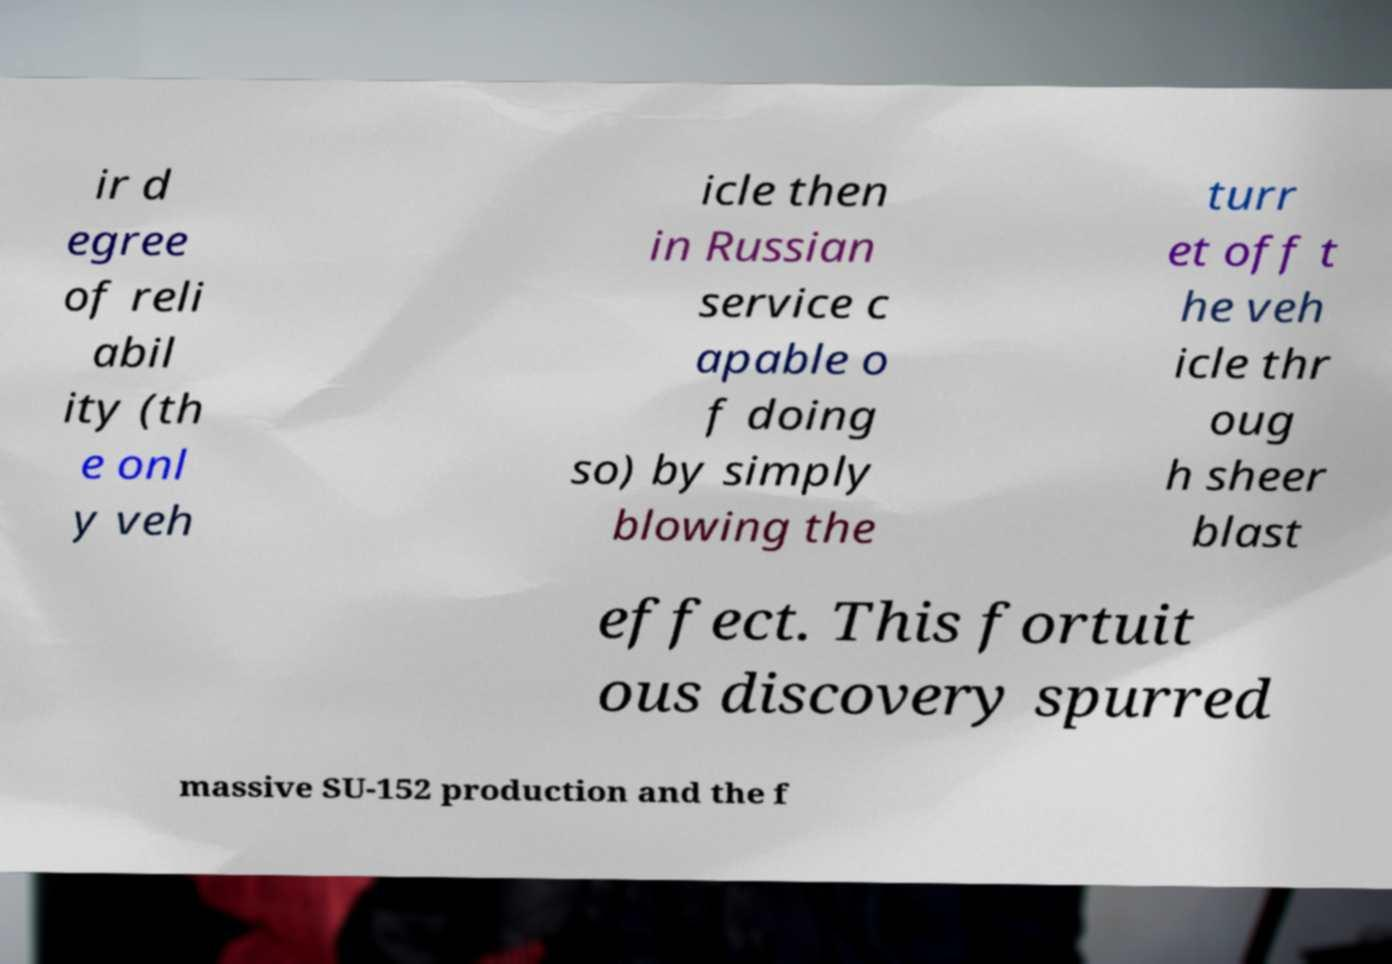For documentation purposes, I need the text within this image transcribed. Could you provide that? ir d egree of reli abil ity (th e onl y veh icle then in Russian service c apable o f doing so) by simply blowing the turr et off t he veh icle thr oug h sheer blast effect. This fortuit ous discovery spurred massive SU-152 production and the f 